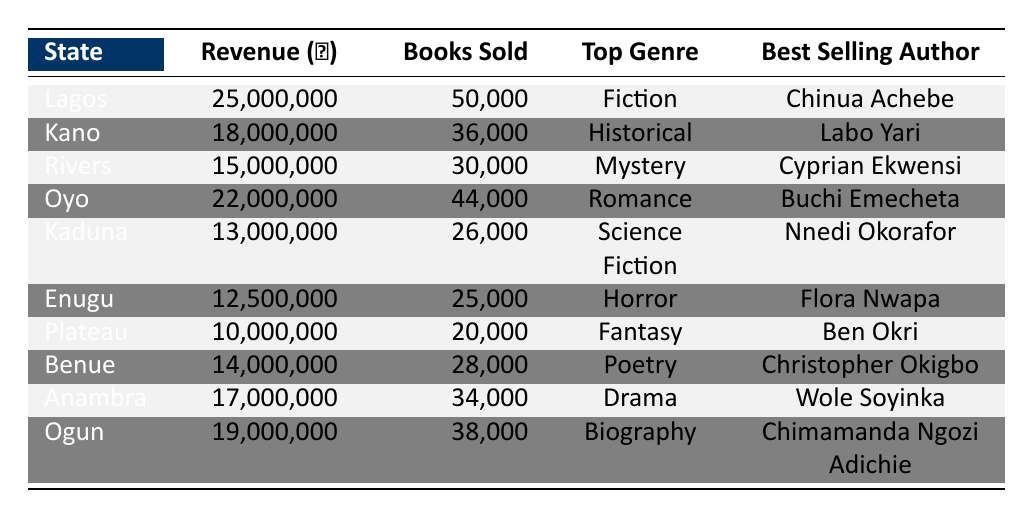What is the top genre of book sales in Lagos? According to the table, Lagos has the top genre listed as Fiction.
Answer: Fiction Which state generated the least revenue from book sales? The table shows that Plateau generated the least revenue at 10,000,000 Naira.
Answer: Plateau How many books were sold in Ogun? The table indicates that Ogun sold 38,000 books.
Answer: 38,000 What is the average revenue across all states listed in the table? To find the average revenue, we sum the revenues: (25,000,000 + 18,000,000 + 15,000,000 + 22,000,000 + 13,000,000 + 12,500,000 + 10,000,000 + 14,000,000 + 17,000,000 + 19,000,000) =  162,500,000. Dividing by the number of states (10) gives an average of 16,250,000 Naira.
Answer: 16,250,000 Is Labo Yari the best-selling author in any state other than Kano? The table only lists Labo Yari as the best-selling author in Kano; therefore, the answer is no, he is not the best-selling author in any other state.
Answer: No What is the total number of books sold in the top three revenue-generating states? The top three states in revenue are Lagos (50,000), Oyo (44,000), and Ogun (38,000). Adding these gives us a total of 50,000 + 44,000 + 38,000 = 132,000 books sold in these states.
Answer: 132,000 Is the best-selling author in Rivers also recognized for a genre that is the same as the best-selling author in Kaduna? The best-selling author in Rivers is Cyprian Ekwensi known for Mystery, while in Kaduna it is Nnedi Okorafor known for Science Fiction. Since these genres differ, the answer is no.
Answer: No What state has the highest revenue from book sales among the listed states? The table indicates that Lagos has the highest revenue at 25,000,000 Naira, more than any other state.
Answer: Lagos 